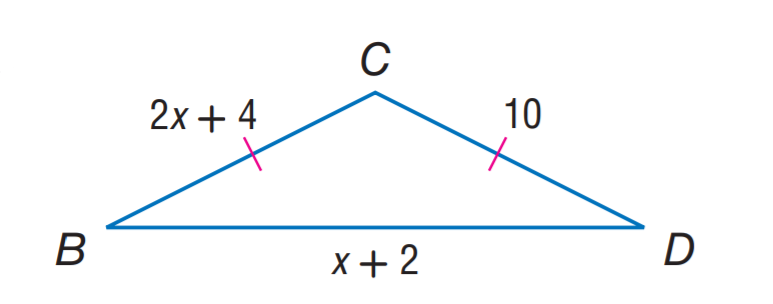Question: Find B C.
Choices:
A. 5
B. 8
C. 10
D. 12
Answer with the letter. Answer: C Question: Find x.
Choices:
A. 2
B. 3
C. 4
D. 5
Answer with the letter. Answer: B Question: Find B D.
Choices:
A. 3
B. 4
C. 5
D. 6
Answer with the letter. Answer: C 